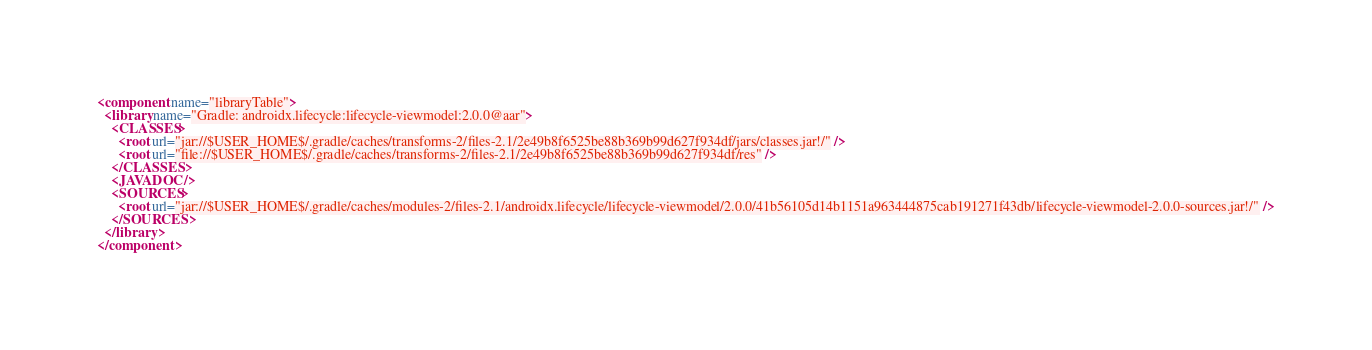Convert code to text. <code><loc_0><loc_0><loc_500><loc_500><_XML_><component name="libraryTable">
  <library name="Gradle: androidx.lifecycle:lifecycle-viewmodel:2.0.0@aar">
    <CLASSES>
      <root url="jar://$USER_HOME$/.gradle/caches/transforms-2/files-2.1/2e49b8f6525be88b369b99d627f934df/jars/classes.jar!/" />
      <root url="file://$USER_HOME$/.gradle/caches/transforms-2/files-2.1/2e49b8f6525be88b369b99d627f934df/res" />
    </CLASSES>
    <JAVADOC />
    <SOURCES>
      <root url="jar://$USER_HOME$/.gradle/caches/modules-2/files-2.1/androidx.lifecycle/lifecycle-viewmodel/2.0.0/41b56105d14b1151a963444875cab191271f43db/lifecycle-viewmodel-2.0.0-sources.jar!/" />
    </SOURCES>
  </library>
</component></code> 